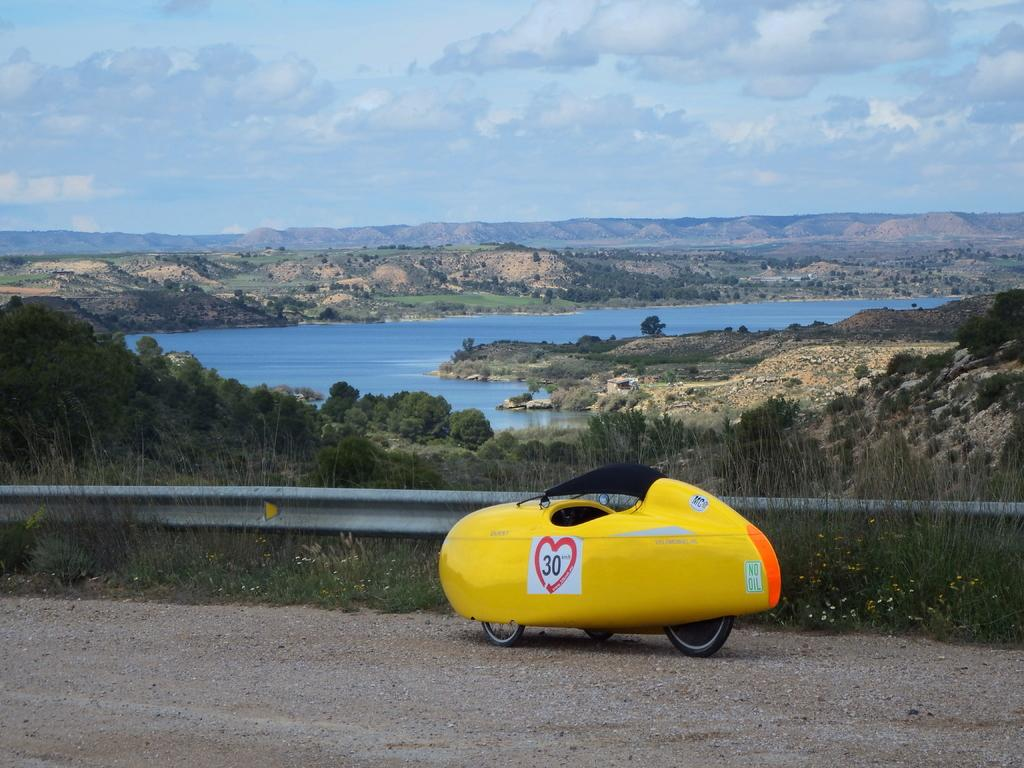What type of vehicle is in the image? There is a three-wheeler vehicle in the image. Where is the vehicle located? The vehicle is on the road. What can be seen in the background of the image? There is a lake, trees, and mountains in the background of the image. What is visible in the sky? There are clouds in the sky. What type of cloth is being rubbed on the vehicle in the image? There is no cloth being rubbed on the vehicle in the image. Is the image taken during winter? The provided facts do not mention any seasonal information, so we cannot determine if the image was taken during winter. 